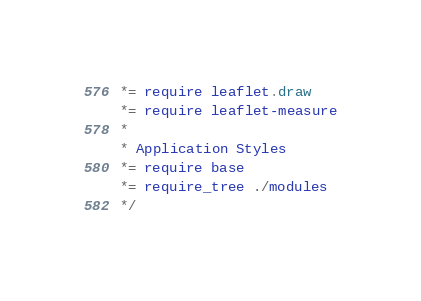<code> <loc_0><loc_0><loc_500><loc_500><_CSS_> *= require leaflet.draw
 *= require leaflet-measure
 *
 * Application Styles
 *= require base
 *= require_tree ./modules
 */
</code> 